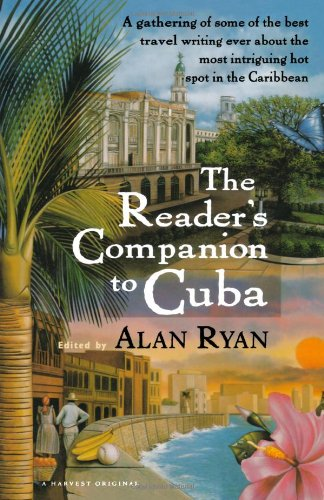Who wrote this book?
Answer the question using a single word or phrase. Alan Ryan What is the title of this book? The Reader's Companion to Cuba What is the genre of this book? Travel Is this book related to Travel? Yes Is this book related to Children's Books? No 